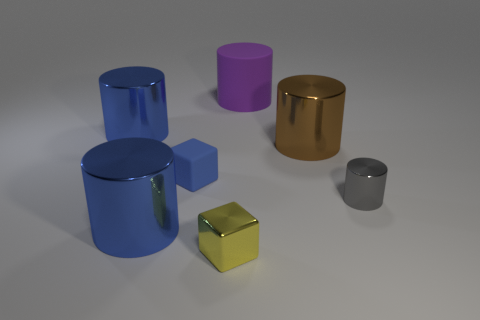Subtract all rubber cylinders. How many cylinders are left? 4 Subtract all red balls. How many blue cylinders are left? 2 Subtract all purple cylinders. How many cylinders are left? 4 Subtract 3 cylinders. How many cylinders are left? 2 Add 2 yellow shiny cylinders. How many objects exist? 9 Subtract all blocks. How many objects are left? 5 Subtract all yellow cylinders. Subtract all green spheres. How many cylinders are left? 5 Subtract all brown cylinders. Subtract all blue cubes. How many objects are left? 5 Add 6 rubber cubes. How many rubber cubes are left? 7 Add 7 rubber cylinders. How many rubber cylinders exist? 8 